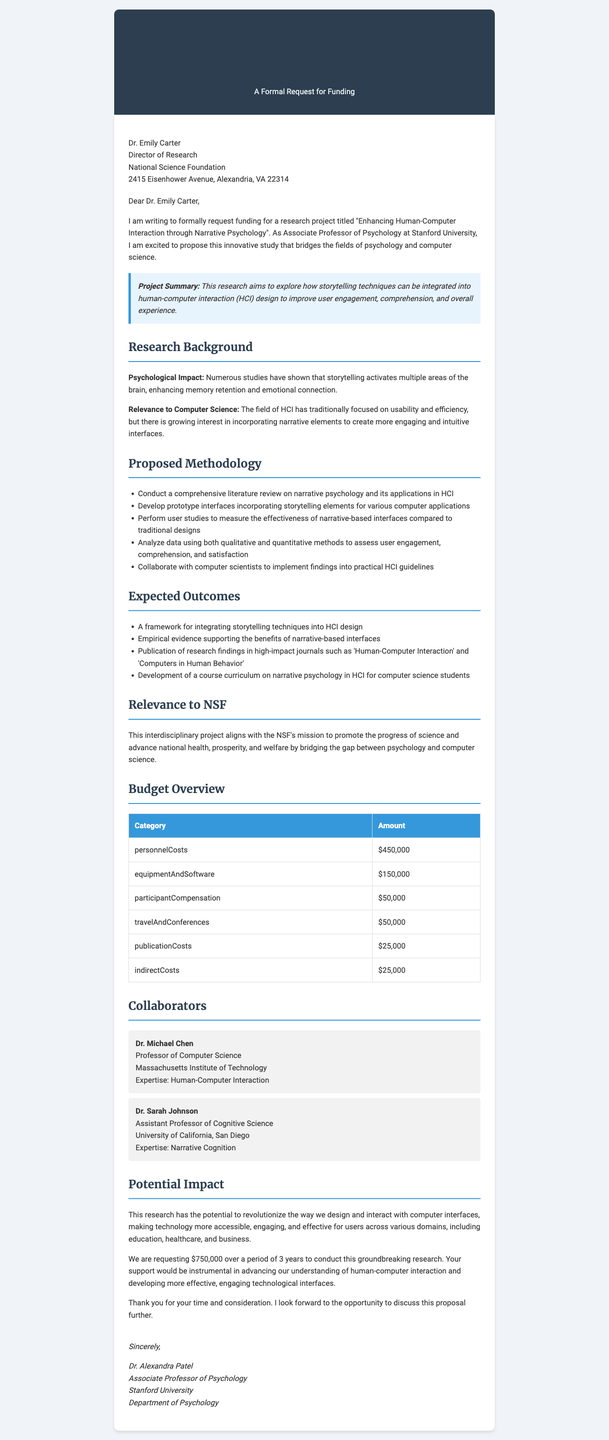What is the recipient's name? The recipient's name is specified in the letter details section, which lists "Dr. Emily Carter" as the recipient.
Answer: Dr. Emily Carter What is the title of the research project? The title of the research project is mentioned prominently at the beginning of the letter.
Answer: Enhancing Human-Computer Interaction through Narrative Psychology How much funding is requested? The amount requested for funding is stated clearly in the funding request section.
Answer: $750,000 What is the duration of the proposed research? The duration of the research is specified in the funding request section.
Answer: 3 years Who is the principal investigator of the project? The principal investigator is mentioned in the researcher information section of the letter.
Answer: Dr. Alexandra Patel What are the expected outcomes of the project? Expected outcomes are listed in a bulleted format; one can reference these outcomes for specifics.
Answer: A framework for integrating storytelling techniques into HCI design What is the relevance of the project to the NSF? The relevance of the project is explained in a specific paragraph detailing how it aligns with the NSF's mission.
Answer: Bridging the gap between psychology and computer science What type of studies will be performed to measure effectiveness? This methodology is described in the proposed methodology section, indicating the nature of the studies conducted.
Answer: User studies Who is a collaborator in this research project? The collaborator details are listed; one of the collaborators is named directly in the document.
Answer: Dr. Michael Chen 